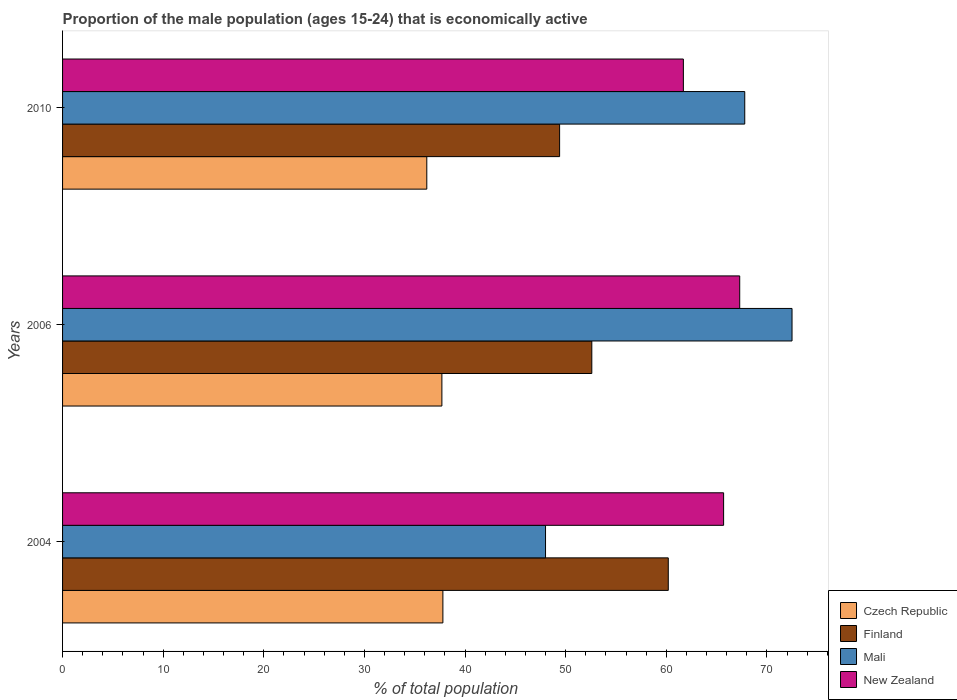How many groups of bars are there?
Your answer should be compact. 3. Are the number of bars per tick equal to the number of legend labels?
Offer a terse response. Yes. How many bars are there on the 1st tick from the top?
Ensure brevity in your answer.  4. In how many cases, is the number of bars for a given year not equal to the number of legend labels?
Your answer should be compact. 0. What is the proportion of the male population that is economically active in Finland in 2010?
Make the answer very short. 49.4. Across all years, what is the maximum proportion of the male population that is economically active in New Zealand?
Make the answer very short. 67.3. Across all years, what is the minimum proportion of the male population that is economically active in New Zealand?
Ensure brevity in your answer.  61.7. In which year was the proportion of the male population that is economically active in Czech Republic minimum?
Your answer should be compact. 2010. What is the total proportion of the male population that is economically active in Mali in the graph?
Make the answer very short. 188.3. What is the difference between the proportion of the male population that is economically active in Mali in 2004 and that in 2006?
Make the answer very short. -24.5. What is the difference between the proportion of the male population that is economically active in Czech Republic in 2004 and the proportion of the male population that is economically active in Finland in 2006?
Your answer should be compact. -14.8. What is the average proportion of the male population that is economically active in New Zealand per year?
Make the answer very short. 64.9. In the year 2004, what is the difference between the proportion of the male population that is economically active in Czech Republic and proportion of the male population that is economically active in Mali?
Your response must be concise. -10.2. In how many years, is the proportion of the male population that is economically active in Czech Republic greater than 10 %?
Your answer should be very brief. 3. What is the ratio of the proportion of the male population that is economically active in Finland in 2004 to that in 2010?
Ensure brevity in your answer.  1.22. Is the proportion of the male population that is economically active in Finland in 2004 less than that in 2006?
Give a very brief answer. No. What is the difference between the highest and the second highest proportion of the male population that is economically active in Mali?
Give a very brief answer. 4.7. What is the difference between the highest and the lowest proportion of the male population that is economically active in Mali?
Ensure brevity in your answer.  24.5. In how many years, is the proportion of the male population that is economically active in New Zealand greater than the average proportion of the male population that is economically active in New Zealand taken over all years?
Your answer should be very brief. 2. Is the sum of the proportion of the male population that is economically active in Mali in 2006 and 2010 greater than the maximum proportion of the male population that is economically active in Finland across all years?
Ensure brevity in your answer.  Yes. Is it the case that in every year, the sum of the proportion of the male population that is economically active in Mali and proportion of the male population that is economically active in New Zealand is greater than the sum of proportion of the male population that is economically active in Czech Republic and proportion of the male population that is economically active in Finland?
Your response must be concise. No. What does the 4th bar from the top in 2010 represents?
Keep it short and to the point. Czech Republic. What does the 4th bar from the bottom in 2004 represents?
Offer a very short reply. New Zealand. Is it the case that in every year, the sum of the proportion of the male population that is economically active in Czech Republic and proportion of the male population that is economically active in New Zealand is greater than the proportion of the male population that is economically active in Finland?
Offer a terse response. Yes. Are all the bars in the graph horizontal?
Make the answer very short. Yes. How many years are there in the graph?
Provide a succinct answer. 3. Does the graph contain grids?
Provide a succinct answer. No. How many legend labels are there?
Ensure brevity in your answer.  4. What is the title of the graph?
Your response must be concise. Proportion of the male population (ages 15-24) that is economically active. What is the label or title of the X-axis?
Make the answer very short. % of total population. What is the label or title of the Y-axis?
Ensure brevity in your answer.  Years. What is the % of total population of Czech Republic in 2004?
Ensure brevity in your answer.  37.8. What is the % of total population of Finland in 2004?
Keep it short and to the point. 60.2. What is the % of total population of Mali in 2004?
Give a very brief answer. 48. What is the % of total population in New Zealand in 2004?
Give a very brief answer. 65.7. What is the % of total population in Czech Republic in 2006?
Ensure brevity in your answer.  37.7. What is the % of total population in Finland in 2006?
Make the answer very short. 52.6. What is the % of total population in Mali in 2006?
Make the answer very short. 72.5. What is the % of total population in New Zealand in 2006?
Keep it short and to the point. 67.3. What is the % of total population of Czech Republic in 2010?
Keep it short and to the point. 36.2. What is the % of total population of Finland in 2010?
Give a very brief answer. 49.4. What is the % of total population of Mali in 2010?
Ensure brevity in your answer.  67.8. What is the % of total population of New Zealand in 2010?
Your answer should be compact. 61.7. Across all years, what is the maximum % of total population of Czech Republic?
Keep it short and to the point. 37.8. Across all years, what is the maximum % of total population in Finland?
Your answer should be very brief. 60.2. Across all years, what is the maximum % of total population in Mali?
Your response must be concise. 72.5. Across all years, what is the maximum % of total population of New Zealand?
Give a very brief answer. 67.3. Across all years, what is the minimum % of total population in Czech Republic?
Your answer should be very brief. 36.2. Across all years, what is the minimum % of total population of Finland?
Make the answer very short. 49.4. Across all years, what is the minimum % of total population in New Zealand?
Your response must be concise. 61.7. What is the total % of total population in Czech Republic in the graph?
Make the answer very short. 111.7. What is the total % of total population of Finland in the graph?
Your answer should be compact. 162.2. What is the total % of total population of Mali in the graph?
Your answer should be compact. 188.3. What is the total % of total population in New Zealand in the graph?
Keep it short and to the point. 194.7. What is the difference between the % of total population of Czech Republic in 2004 and that in 2006?
Ensure brevity in your answer.  0.1. What is the difference between the % of total population of Mali in 2004 and that in 2006?
Offer a very short reply. -24.5. What is the difference between the % of total population in New Zealand in 2004 and that in 2006?
Provide a succinct answer. -1.6. What is the difference between the % of total population of Czech Republic in 2004 and that in 2010?
Make the answer very short. 1.6. What is the difference between the % of total population of Mali in 2004 and that in 2010?
Your response must be concise. -19.8. What is the difference between the % of total population in New Zealand in 2004 and that in 2010?
Provide a short and direct response. 4. What is the difference between the % of total population of Finland in 2006 and that in 2010?
Make the answer very short. 3.2. What is the difference between the % of total population of Mali in 2006 and that in 2010?
Offer a very short reply. 4.7. What is the difference between the % of total population of Czech Republic in 2004 and the % of total population of Finland in 2006?
Offer a terse response. -14.8. What is the difference between the % of total population in Czech Republic in 2004 and the % of total population in Mali in 2006?
Your answer should be compact. -34.7. What is the difference between the % of total population in Czech Republic in 2004 and the % of total population in New Zealand in 2006?
Offer a very short reply. -29.5. What is the difference between the % of total population in Mali in 2004 and the % of total population in New Zealand in 2006?
Give a very brief answer. -19.3. What is the difference between the % of total population of Czech Republic in 2004 and the % of total population of New Zealand in 2010?
Offer a terse response. -23.9. What is the difference between the % of total population of Finland in 2004 and the % of total population of Mali in 2010?
Provide a succinct answer. -7.6. What is the difference between the % of total population in Finland in 2004 and the % of total population in New Zealand in 2010?
Your response must be concise. -1.5. What is the difference between the % of total population of Mali in 2004 and the % of total population of New Zealand in 2010?
Offer a terse response. -13.7. What is the difference between the % of total population in Czech Republic in 2006 and the % of total population in Mali in 2010?
Keep it short and to the point. -30.1. What is the difference between the % of total population of Czech Republic in 2006 and the % of total population of New Zealand in 2010?
Ensure brevity in your answer.  -24. What is the difference between the % of total population in Finland in 2006 and the % of total population in Mali in 2010?
Offer a terse response. -15.2. What is the average % of total population of Czech Republic per year?
Offer a very short reply. 37.23. What is the average % of total population of Finland per year?
Offer a very short reply. 54.07. What is the average % of total population in Mali per year?
Keep it short and to the point. 62.77. What is the average % of total population in New Zealand per year?
Offer a very short reply. 64.9. In the year 2004, what is the difference between the % of total population of Czech Republic and % of total population of Finland?
Your response must be concise. -22.4. In the year 2004, what is the difference between the % of total population in Czech Republic and % of total population in New Zealand?
Your response must be concise. -27.9. In the year 2004, what is the difference between the % of total population in Finland and % of total population in Mali?
Offer a terse response. 12.2. In the year 2004, what is the difference between the % of total population of Finland and % of total population of New Zealand?
Your answer should be compact. -5.5. In the year 2004, what is the difference between the % of total population in Mali and % of total population in New Zealand?
Your answer should be very brief. -17.7. In the year 2006, what is the difference between the % of total population of Czech Republic and % of total population of Finland?
Your response must be concise. -14.9. In the year 2006, what is the difference between the % of total population of Czech Republic and % of total population of Mali?
Your answer should be very brief. -34.8. In the year 2006, what is the difference between the % of total population of Czech Republic and % of total population of New Zealand?
Offer a terse response. -29.6. In the year 2006, what is the difference between the % of total population in Finland and % of total population in Mali?
Your answer should be very brief. -19.9. In the year 2006, what is the difference between the % of total population of Finland and % of total population of New Zealand?
Your response must be concise. -14.7. In the year 2006, what is the difference between the % of total population of Mali and % of total population of New Zealand?
Your answer should be compact. 5.2. In the year 2010, what is the difference between the % of total population of Czech Republic and % of total population of Mali?
Keep it short and to the point. -31.6. In the year 2010, what is the difference between the % of total population of Czech Republic and % of total population of New Zealand?
Provide a succinct answer. -25.5. In the year 2010, what is the difference between the % of total population in Finland and % of total population in Mali?
Provide a succinct answer. -18.4. In the year 2010, what is the difference between the % of total population in Finland and % of total population in New Zealand?
Provide a succinct answer. -12.3. What is the ratio of the % of total population of Czech Republic in 2004 to that in 2006?
Offer a terse response. 1. What is the ratio of the % of total population of Finland in 2004 to that in 2006?
Your answer should be very brief. 1.14. What is the ratio of the % of total population of Mali in 2004 to that in 2006?
Ensure brevity in your answer.  0.66. What is the ratio of the % of total population of New Zealand in 2004 to that in 2006?
Your answer should be very brief. 0.98. What is the ratio of the % of total population of Czech Republic in 2004 to that in 2010?
Provide a short and direct response. 1.04. What is the ratio of the % of total population of Finland in 2004 to that in 2010?
Your answer should be compact. 1.22. What is the ratio of the % of total population of Mali in 2004 to that in 2010?
Your answer should be compact. 0.71. What is the ratio of the % of total population in New Zealand in 2004 to that in 2010?
Ensure brevity in your answer.  1.06. What is the ratio of the % of total population in Czech Republic in 2006 to that in 2010?
Offer a very short reply. 1.04. What is the ratio of the % of total population in Finland in 2006 to that in 2010?
Provide a short and direct response. 1.06. What is the ratio of the % of total population of Mali in 2006 to that in 2010?
Give a very brief answer. 1.07. What is the ratio of the % of total population of New Zealand in 2006 to that in 2010?
Make the answer very short. 1.09. What is the difference between the highest and the second highest % of total population of New Zealand?
Offer a terse response. 1.6. 